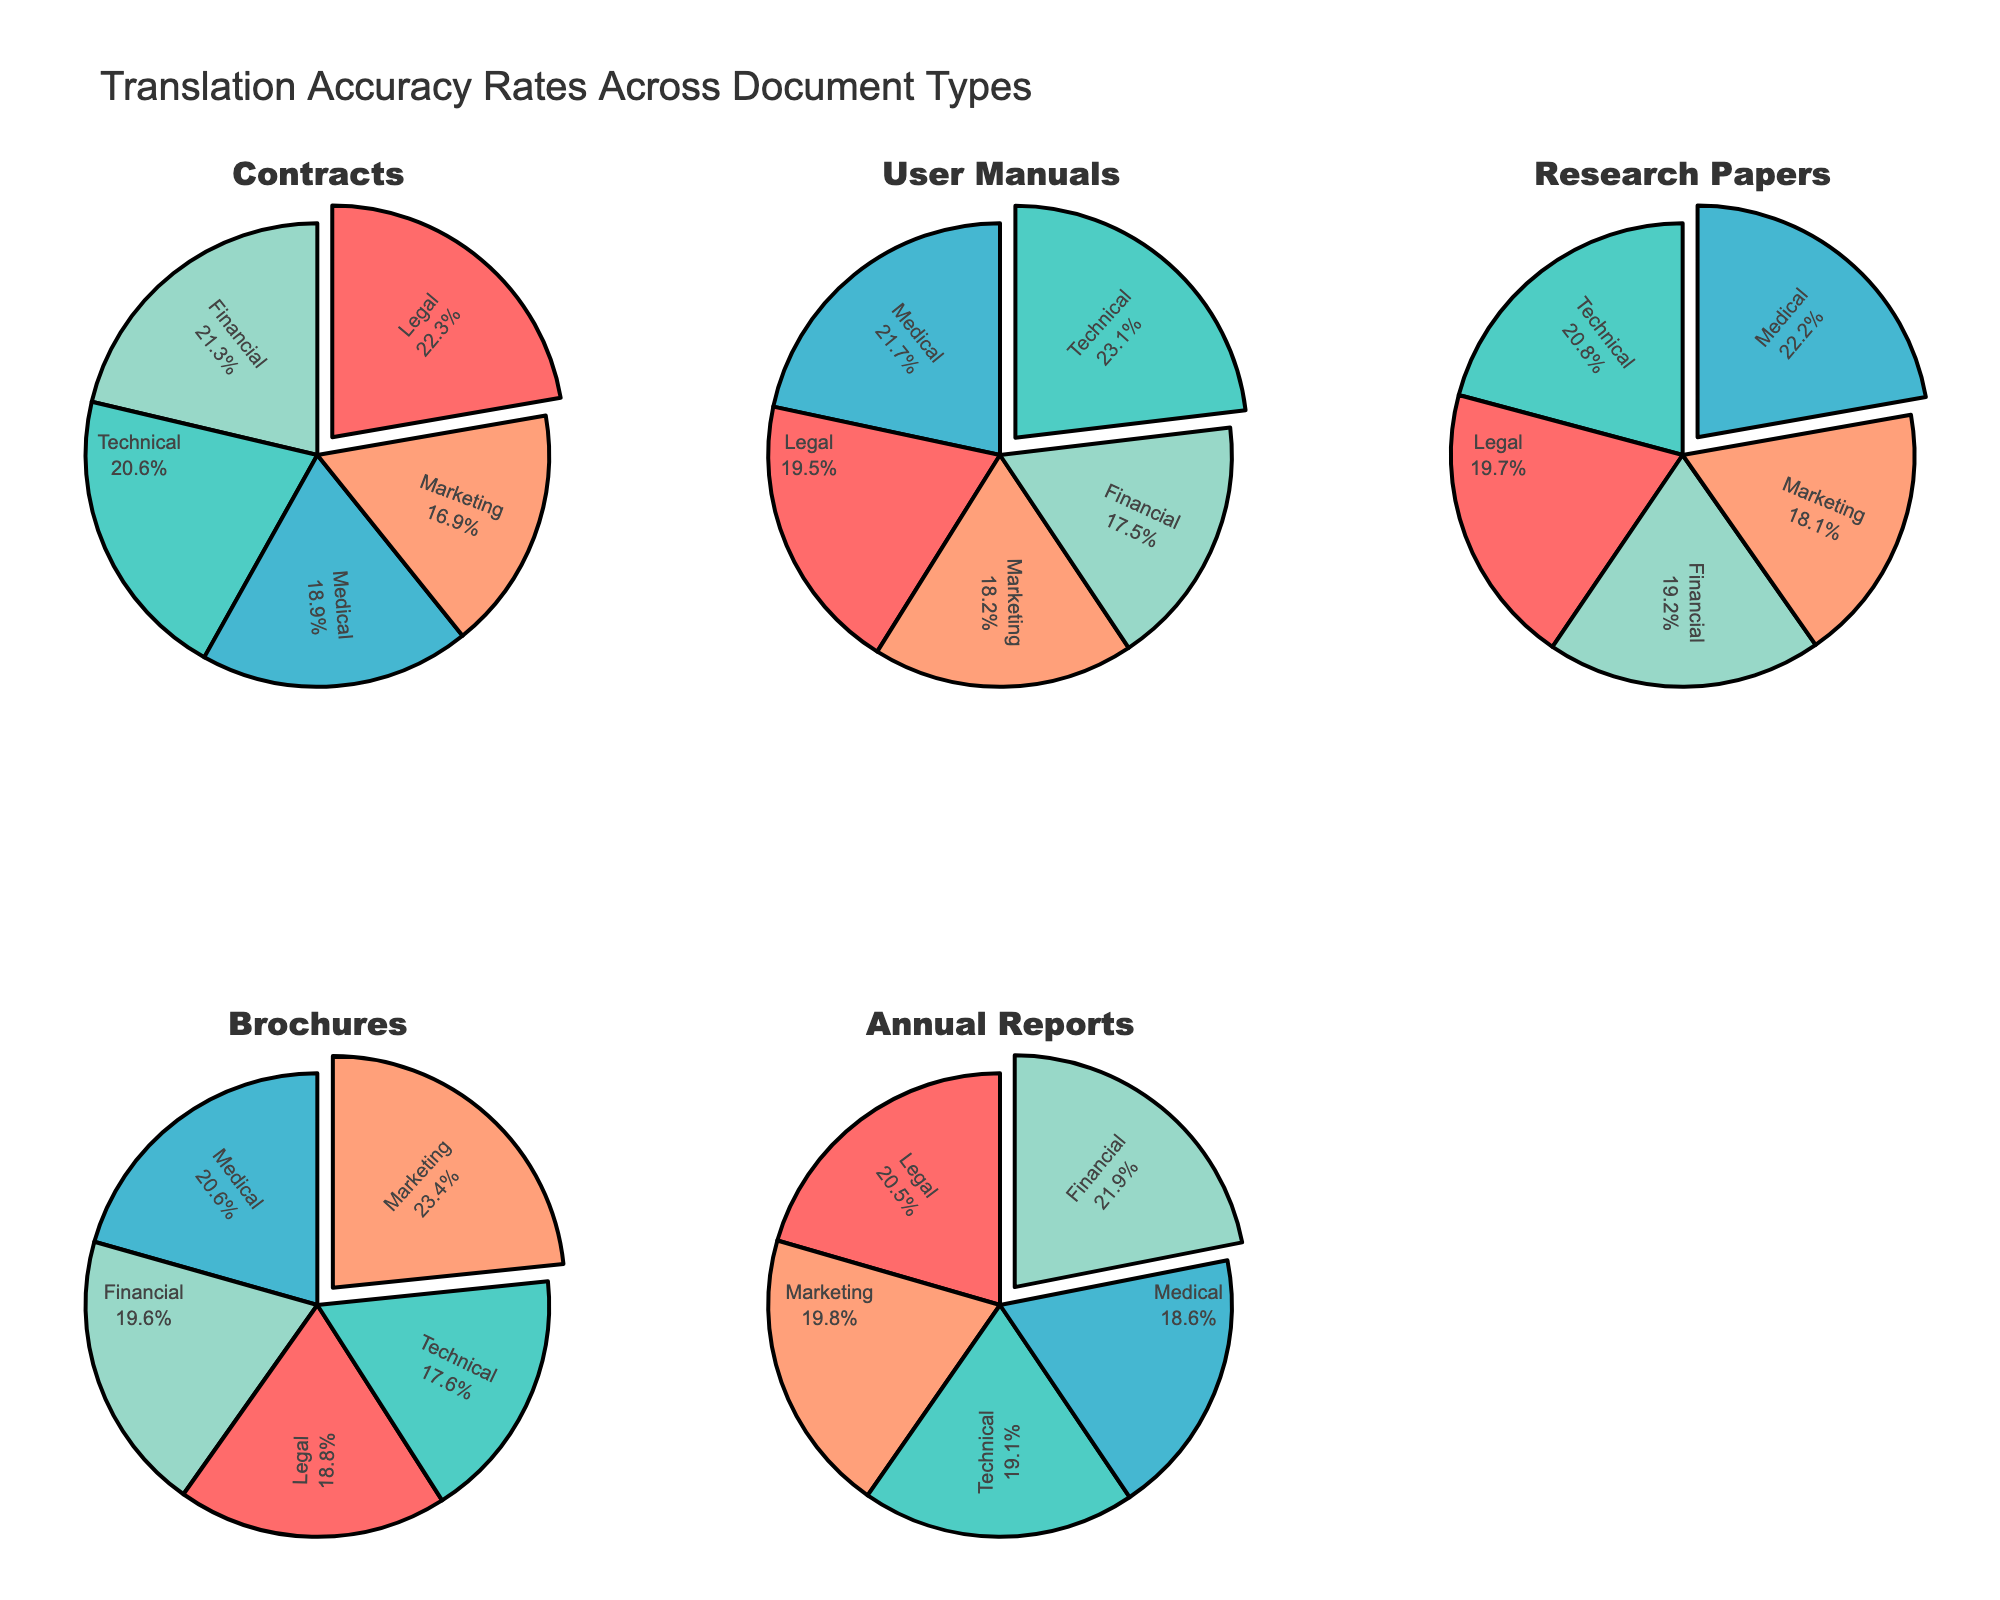What is the title of the figure? The title is found at the top center of the figure and describes the content of the plot.
Answer: Translation Accuracy Rates Across Document Types Which document type has the highest translation accuracy rate for Medical documents? Examine the slice of the pie chart for "Medical" in each document type and identify the one with the largest percentage.
Answer: Research Papers What is the difference in translation accuracy rates between Contracts and Brochures for the Financial category? Locate the Financial category in the pie charts for both Contracts and Brochures, then calculate the difference. Contracts' accuracy is 88%, and Brochures' accuracy is 78%, so the difference is 88% - 78%.
Answer: 10% Which document type has the most even distribution of translation accuracy rates across all categories? Look at each pie chart and evaluate which one has the slices closest in size (percentages).
Answer: Annual Reports Which category has the highest translation accuracy rate in the pie chart for Marketing? Refer to the Marketing segment in the subplots: Contracts, User Manuals, Research Papers, Brochures, and Annual Reports, and identify the highest value among these charts.
Answer: Brochures Across all document types, which category appears most frequently as the highest translation accuracy rate? Go through each pie chart and check which category segment is the largest slice most often.
Answer: Financial In the Research Papers document type, what is the second-highest translation accuracy rate and for which category? Find the largest slice first for Research Papers, then identify the second-largest slice and its category.
Answer: Medical; 96% How much more accurate is translation for User Manuals in the Technical category compared to the Marketing category? Compare the percentage for User Manuals in the Technical and Marketing categories and subtract the smaller percentage from the larger one: 95% - 75%.
Answer: 20% Among the Financial category, which document type shows the lowest translation accuracy rate? Identify the segment representing the Financial category in each document type's pie chart and look for the smallest percentage.
Answer: User Manuals For the Contracts document type, calculate the average translation accuracy rate across all categories. Add up the translation accuracy percentages for Contracts across all categories and divide by the number of categories: (92 + 85 + 78 + 70 + 88) / 5.
Answer: 82.6% 